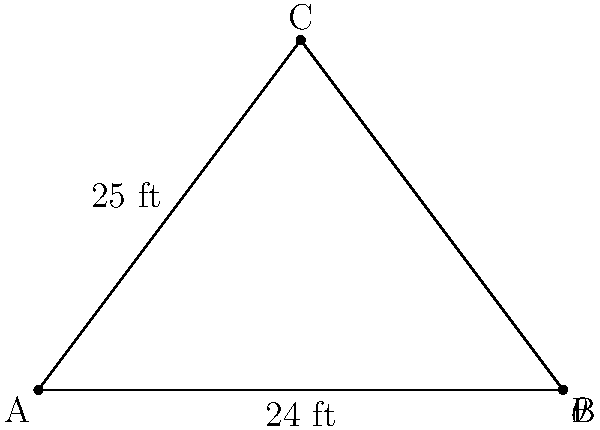Your childhood friend is renovating their house and needs help calculating the roof pitch. The width of the building is 24 feet, and the length of each rafter is 25 feet. What is the angle $\theta$ of the roof pitch? To solve this problem, we'll use trigonometry, specifically the cosine function. Let's approach this step-by-step:

1) In the right triangle formed by half of the roof:
   - The hypotenuse is the rafter length: 25 ft
   - The adjacent side is half the width of the building: 24/2 = 12 ft
   - The angle we're looking for is $\theta$

2) The cosine of an angle in a right triangle is the ratio of the adjacent side to the hypotenuse:

   $$\cos \theta = \frac{\text{adjacent}}{\text{hypotenuse}} = \frac{12}{25}$$

3) To find $\theta$, we need to take the inverse cosine (arccos) of both sides:

   $$\theta = \arccos(\frac{12}{25})$$

4) Using a calculator or computer:

   $$\theta \approx 61.93^\circ$$

5) Round to the nearest degree:

   $$\theta \approx 62^\circ$$
Answer: $62^\circ$ 